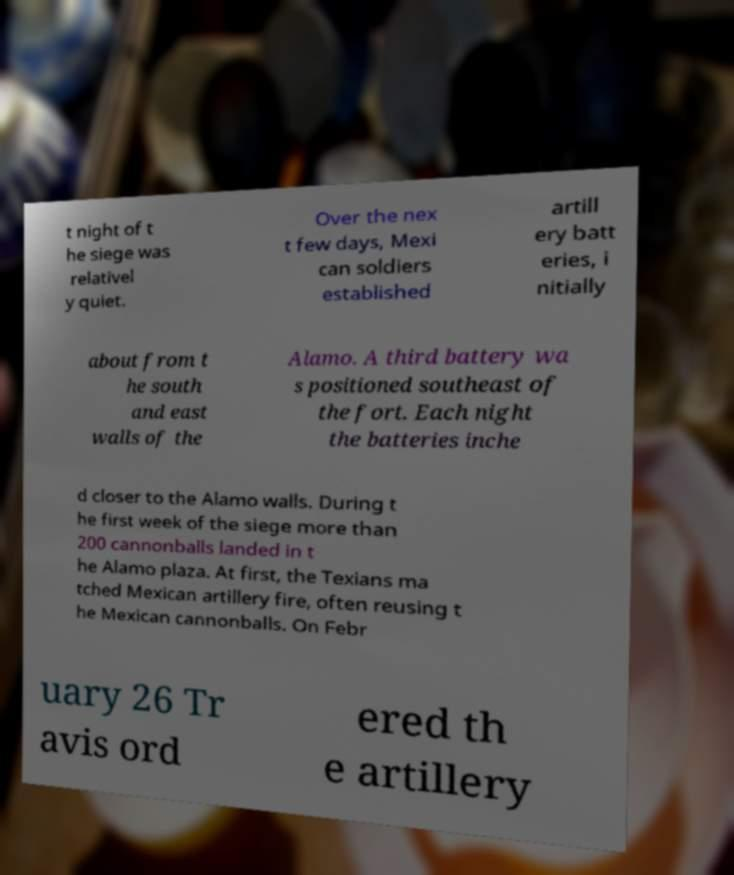Could you assist in decoding the text presented in this image and type it out clearly? t night of t he siege was relativel y quiet. Over the nex t few days, Mexi can soldiers established artill ery batt eries, i nitially about from t he south and east walls of the Alamo. A third battery wa s positioned southeast of the fort. Each night the batteries inche d closer to the Alamo walls. During t he first week of the siege more than 200 cannonballs landed in t he Alamo plaza. At first, the Texians ma tched Mexican artillery fire, often reusing t he Mexican cannonballs. On Febr uary 26 Tr avis ord ered th e artillery 